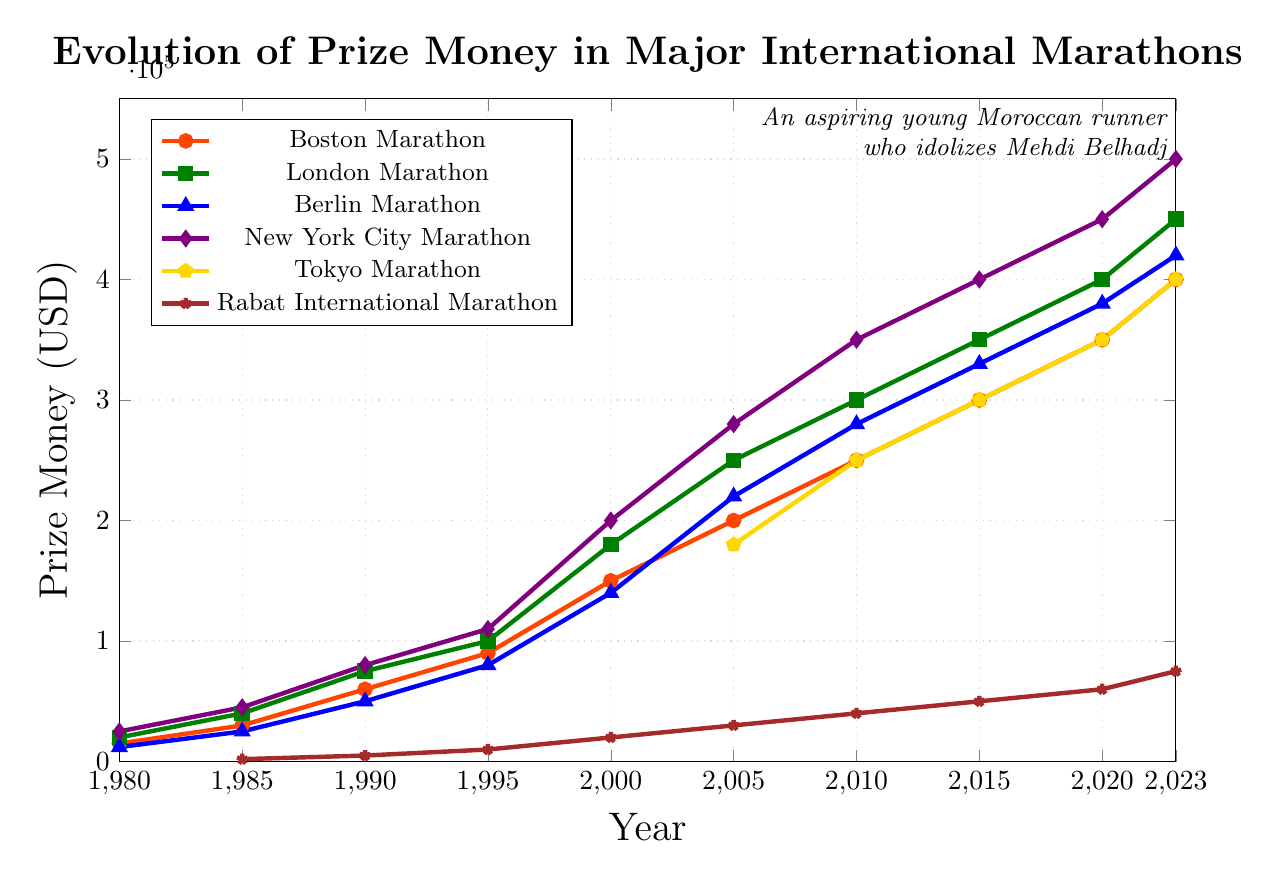Which marathon had the highest prize money in 2023? In 2023, we look at the height of each line at the very right end of the graph. The New York City Marathon has the highest prize money.
Answer: New York City Marathon What was the prize money for the Rabat International Marathon in 2005? Locate the point corresponding to the Rabat International Marathon (brown star symbol) in the year 2005 on the x-axis. The value is 30000.
Answer: 30000 Which marathon showed the biggest increase in prize money between 1980 and 2023? Compare the gap between the points in 1980 and 2023 for each marathon. The London Marathon went from 20000 to 450000, an increase of 430000, which is the largest.
Answer: London Marathon How does the prize money for the Tokyo Marathon in 2010 compare to that of the Berlin Marathon in the same year? Find the prize money for both marathons in 2010 from their respective lines: Tokyo Marathon (yellow pentagon) is at 250000, and Berlin Marathon (blue triangle) is at 280000.
Answer: Berlin Marathon has higher prize money What is the average prize money for the New York City Marathon from 1980 to 2023? Add the prize money values of the New York City Marathon across all the years: 25000, 45000, 80000, 110000, 200000, 280000, 350000, 400000, 450000, 500000. Sum these values (2435000) and divide by the number of years (10).
Answer: 243500 What is the difference in prize money between the Berlin Marathon and the Rabat International Marathon in 2023? Subtract the 2023 prize money for the Rabat International Marathon (75000) from that of the Berlin Marathon (420000).
Answer: 345000 Between 1990 and 2000, which marathon had the highest increase in prize money? Compare the increase for each marathon between 1990 and 2000: Boston (60000 to 150000), London (75000 to 180000), Berlin (50000 to 140000), New York City (80000 to 200000), and Rabat (5000 to 20000). The New York City Marathon increased by the most (120000).
Answer: New York City Marathon What trend is observed in the prize money for the Rabat International Marathon from 1990 to 2023? Look at the trend line for the Rabat International Marathon (brown star). The prize money shows consistent growth over the years, gradually increasing every period.
Answer: Consistent growth Compare the rate of increase in prize money from 2005 to 2023 for the Boston Marathon and the London Marathon. Calculate the increase for both marathons: Boston (200000 to 400000) is 200000; London (250000 to 450000) is 200000. Since the increase is the same, the rate of increase must depend on the base value. The London Marathon had a higher base value in 2005, so its rate of increase is lower.
Answer: Boston Marathon had a higher rate of increase 